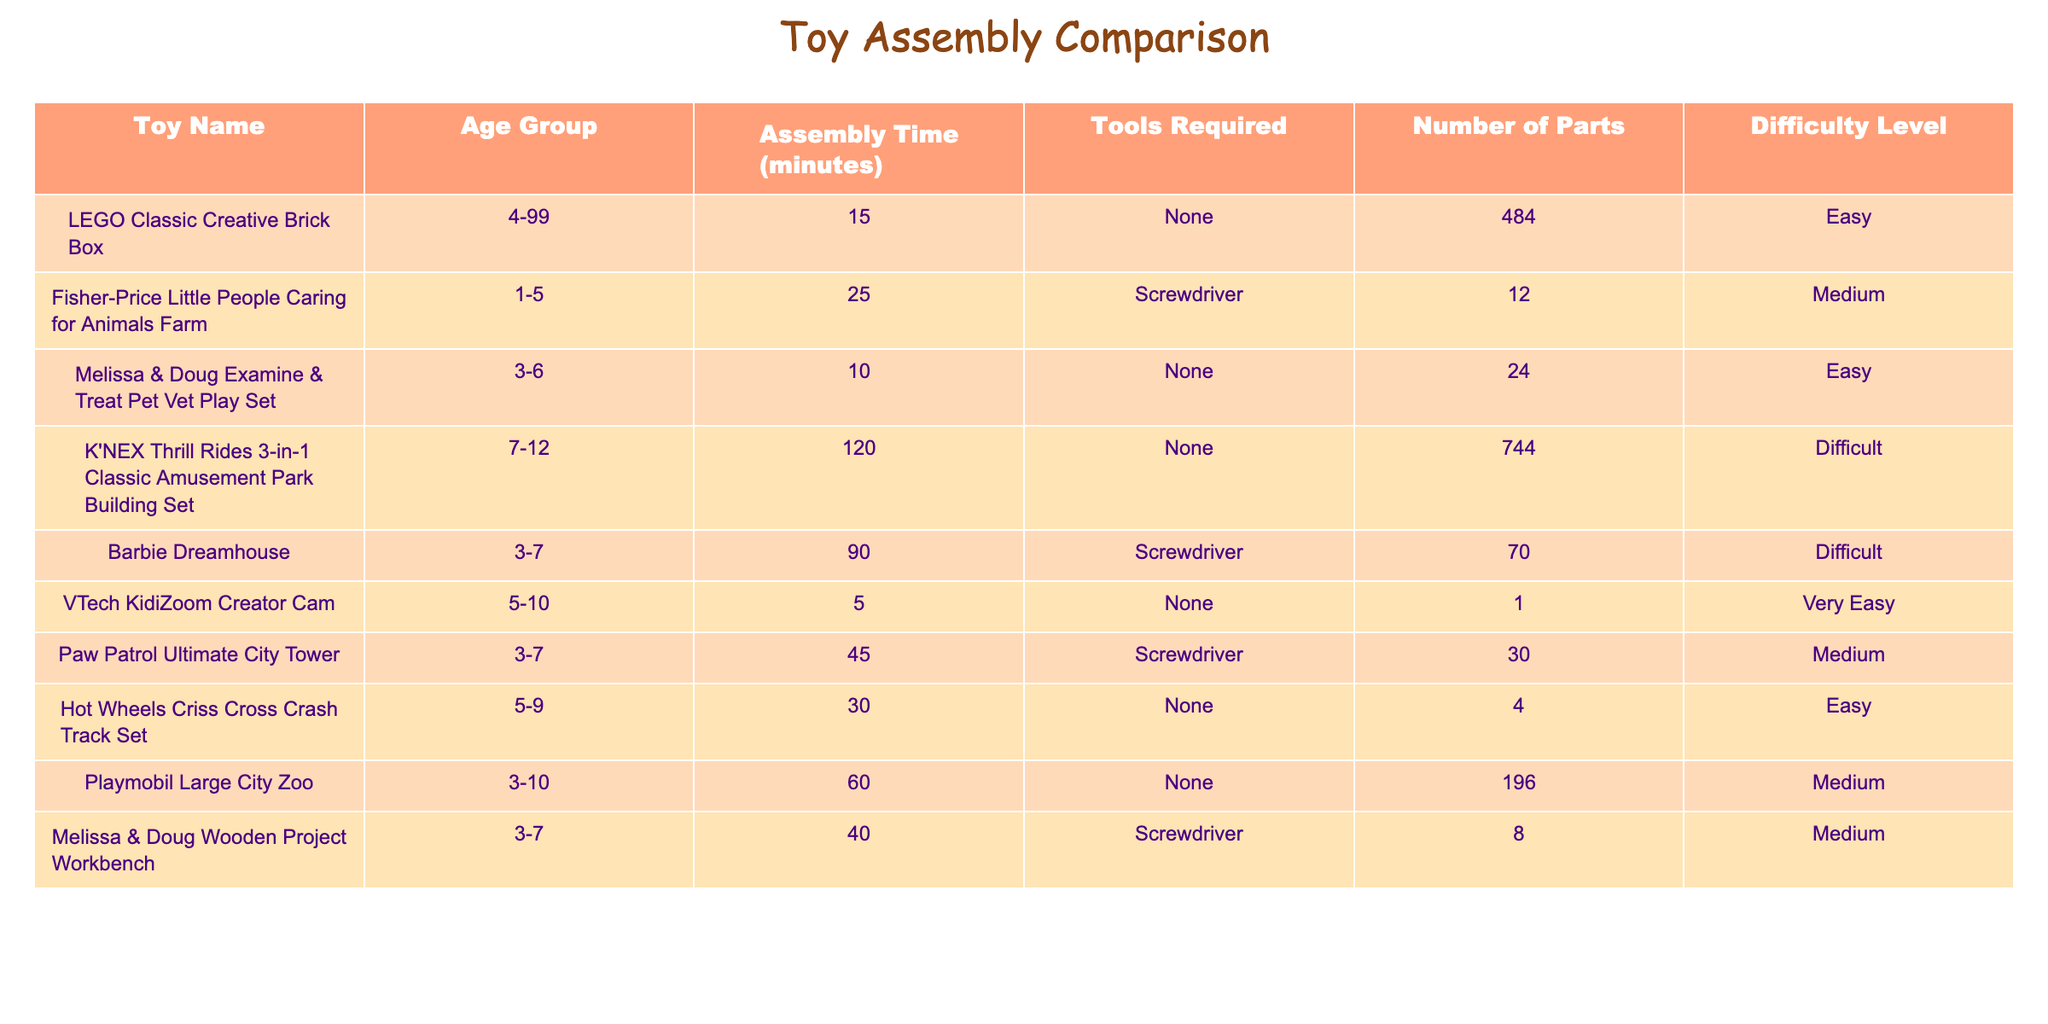What is the assembly time for the Barbie Dreamhouse? The table lists the assembly time for the Barbie Dreamhouse as 90 minutes.
Answer: 90 minutes Which toy has the least assembly time? By reviewing the assembly times in the table, the VTech KidiZoom Creator Cam has the least assembly time at 5 minutes.
Answer: 5 minutes How many parts does the LEGO Classic Creative Brick Box have? According to the table, the LEGO Classic Creative Brick Box has 484 parts.
Answer: 484 parts What is the average assembly time of all the toys listed? To find the average, sum the assembly times: 15 + 25 + 10 + 120 + 90 + 5 + 45 + 30 + 60 + 40 = 430. Then divide by the number of toys (10): 430 / 10 = 43.
Answer: 43 minutes Is the Fisher-Price Little People Caring for Animals Farm easy to assemble? The table indicates that its difficulty level is medium, which means it is not classified as easy to assemble.
Answer: No How many toys require a screwdriver for assembly? The table states that the toys requiring a screwdriver are: Fisher-Price Little People Caring for Animals Farm, Barbie Dreamhouse, Paw Patrol Ultimate City Tower, and Melissa & Doug Wooden Project Workbench, totaling 4 toys.
Answer: 4 toys Which toy has the highest difficulty level? From the table, K'NEX Thrill Rides 3-in-1 Classic Amusement Park Building Set and Barbie Dreamhouse both have a difficulty level classified as difficult, but K'NEX has the highest assembly time.
Answer: K'NEX Thrill Rides 3-in-1 Classic Amusement Park Building Set How much longer does it take to assemble the K'NEX Thrill Rides compared to the VTech KidiZoom Creator Cam? The assembly time for K'NEX Thrill Rides is 120 minutes and for VTech KidiZoom Creator Cam is 5 minutes. The difference is 120 - 5 = 115 minutes.
Answer: 115 minutes What is the total number of parts for all the toys listed? To find the total, sum the number of parts: 484 + 12 + 24 + 744 + 70 + 1 + 30 + 4 + 196 + 8 = 1,579 parts.
Answer: 1,579 parts Is the Melissa & Doug Examine & Treat Pet Vet Play Set easier to assemble than the Paw Patrol Ultimate City Tower? The difficulty level for Melissa & Doug is easy, while Paw Patrol is medium. Since easy is less difficult than medium, it is easier to assemble.
Answer: Yes 